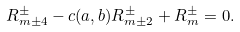Convert formula to latex. <formula><loc_0><loc_0><loc_500><loc_500>R ^ { \pm } _ { m \pm 4 } - c ( a , b ) R ^ { \pm } _ { m \pm 2 } + R ^ { \pm } _ { m } = 0 .</formula> 